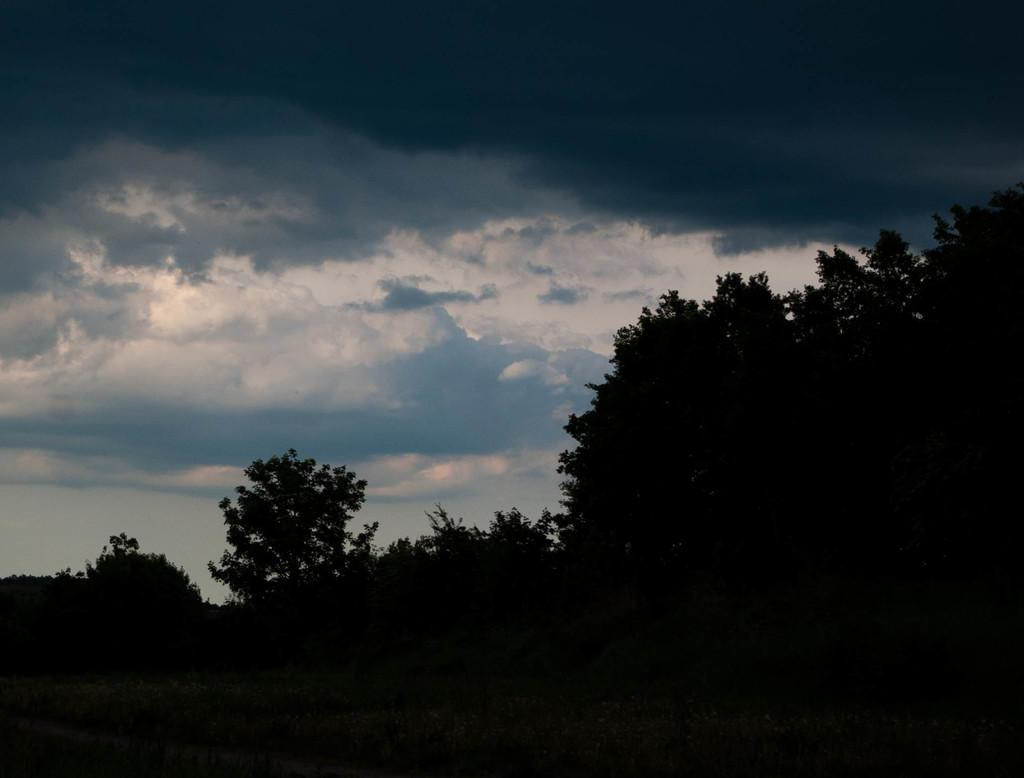What can be seen in the sky in the image? There are clouds in the sky in the image. What type of vegetation is present in the image? There are trees with branches and leaves in the image. What type of cable is connected to the music player in the image? There is no music player or cable present in the image. What color is the notebook on the table in the image? There is no notebook present in the image. 